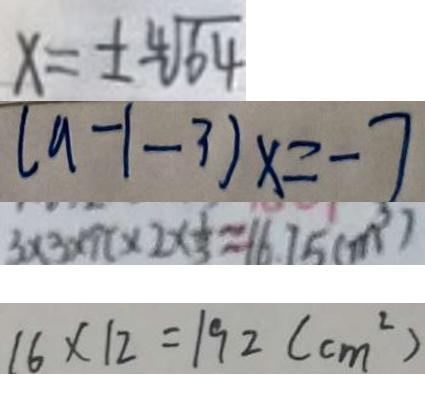<formula> <loc_0><loc_0><loc_500><loc_500>x = \pm \sqrt [ 4 ] { 6 4 } 
 ( a - 1 - 3 ) x = - 7 
 3 \times 3 \times 9 \pi \times 2 \times \frac { 1 } { 3 } \approx 1 6 . 7 5 ( m ^ { 3 } ) 
 1 6 \times 1 2 = 1 9 2 ( c m ^ { 2 } )</formula> 